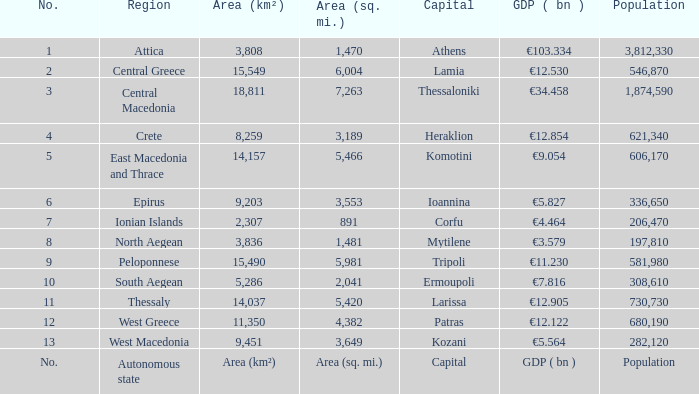What is the population where the area (sq. mi.) is area (sq. mi.)? Population. 